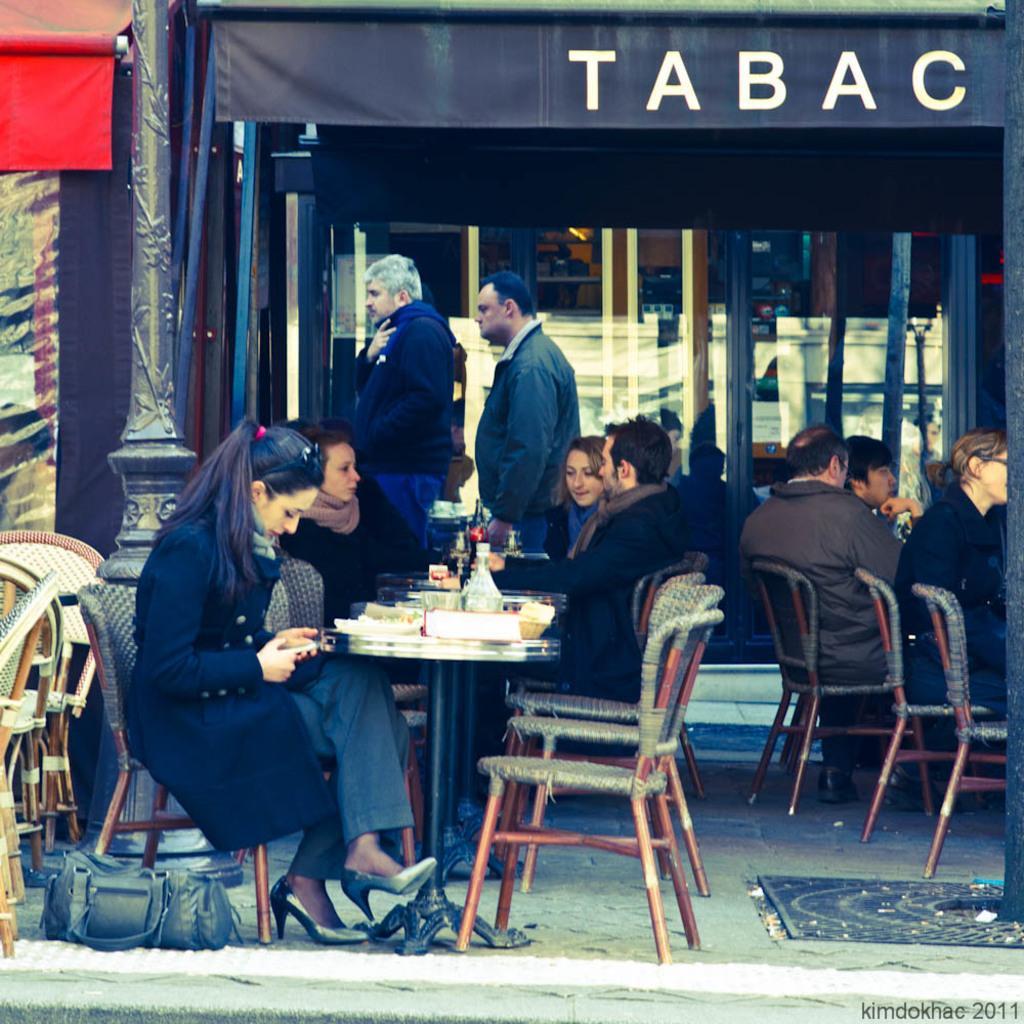Describe this image in one or two sentences. In this picture we can see a group of people some are sitting on chairs and some are standing and in front of them there is table and on table we can see plates, basket, bowl, bottles beside to them we have bags and chairs and in background we can see pillar, glass, sun shade 